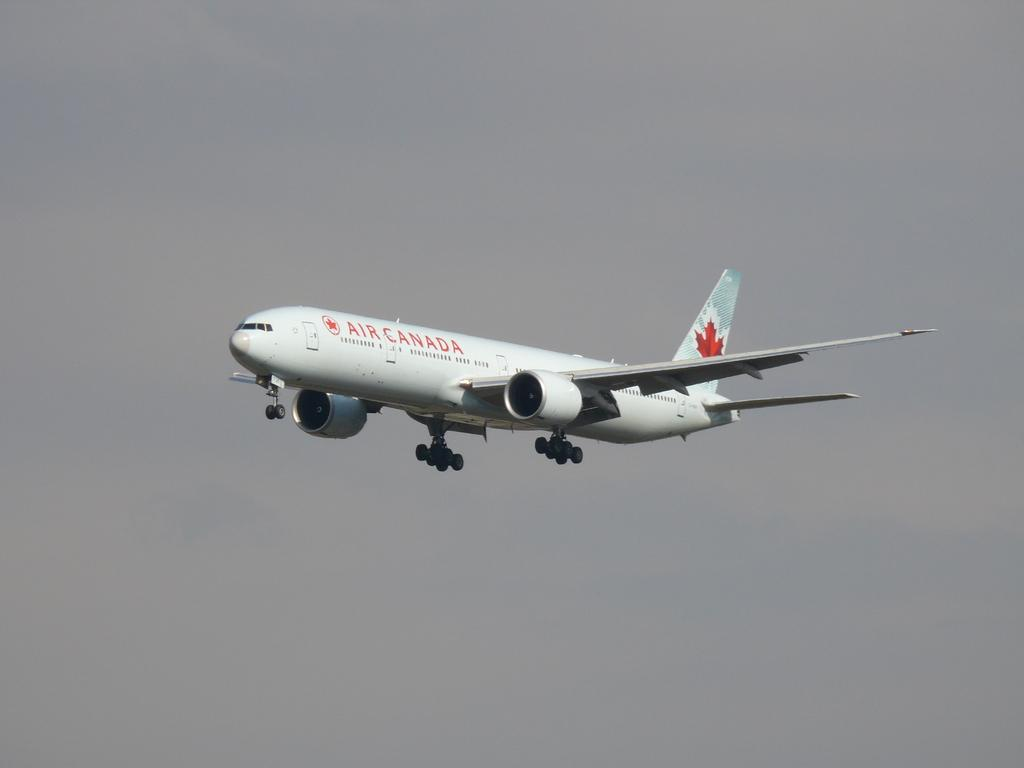What is the main subject of the picture? The main subject of the picture is an airplane. What is the airplane doing in the picture? The airplane is flying in the picture. Can you describe any text or writing on the airplane? Yes, there is something written on the airplane. Is there any symbol or logo on the airplane? Yes, there is a logo on the airplane. How would you describe the sky in the picture? The sky is cloudy in the picture. What type of ice can be seen melting on the airplane's wing in the image? There is no ice visible on the airplane's wing in the image. Can you tell me how many shops are located near the airplane in the image? There are no shops present in the image; it only features an airplane flying in the cloudy sky. 